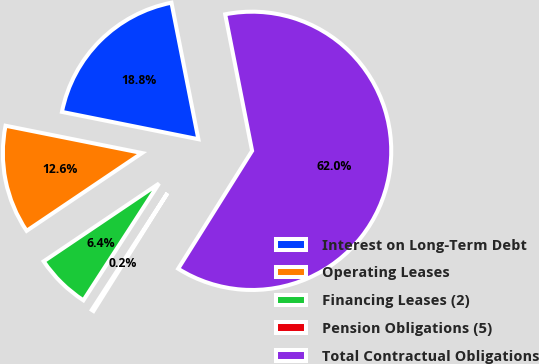Convert chart to OTSL. <chart><loc_0><loc_0><loc_500><loc_500><pie_chart><fcel>Interest on Long-Term Debt<fcel>Operating Leases<fcel>Financing Leases (2)<fcel>Pension Obligations (5)<fcel>Total Contractual Obligations<nl><fcel>18.76%<fcel>12.59%<fcel>6.41%<fcel>0.23%<fcel>62.02%<nl></chart> 